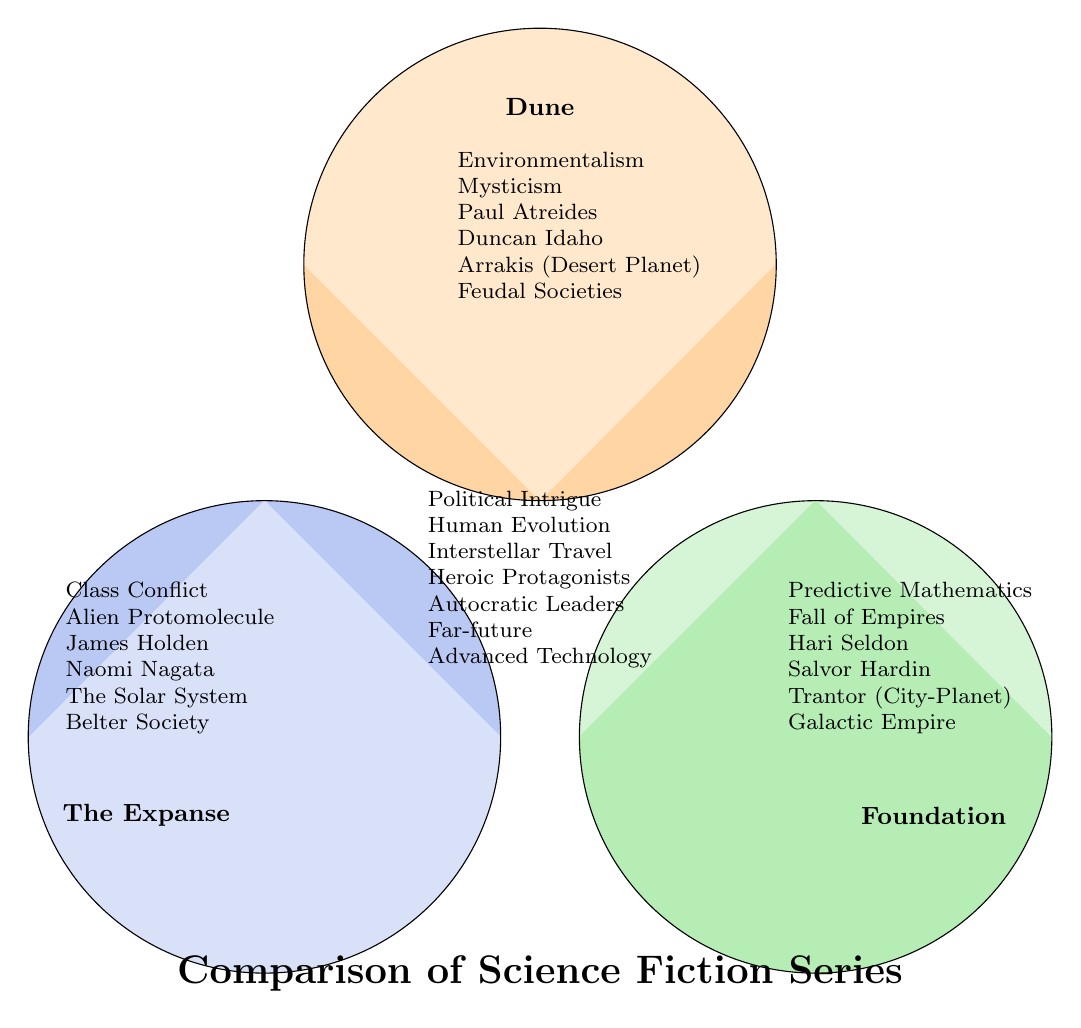What themes are unique to Dune? By examining the "Dune" circle in the Venn diagram, we can see the themes surrounding it, specifically "Environmentalism" and "Mysticism," which are not shared with "The Expanse" or "Foundation."
Answer: Environmentalism, Mysticism What characters are associated with The Expanse? The characters listed within the "The Expanse" section of the diagram include "James Holden" and "Naomi Nagata," which are unique to that series.
Answer: James Holden, Naomi Nagata How many common themes do all three series share? The central overlapping area of the Venn diagram lists common themes, which include six themes: "Political Intrigue," "Human Evolution," "Interstellar Travel," "Heroic Protagonists," "Autocratic Leaders," and "Far-future."
Answer: 6 Which setting is depicted in the Foundation series? In the area designated for "Foundation," the setting listed is "Trantor (City-Planet)," highlighting its unique element compared to the other series.
Answer: Trantor (City-Planet) What is the relationship between Dune and The Expanse? The overlapping section between "Dune" and "The Expanse" contains no information indicating specific shared themes or characters, implying that there are no unique similarities between the two in this diagram.
Answer: None Which character is common to both Dune and Foundation? Upon examining each series, there are no characters listed that overlap between the individual sections of "Dune" and "Foundation," meaning there are no shared characters.
Answer: None How is the theme of "Galactic Empire" represented? The theme of "Galactic Empire" appears uniquely in the "Foundation" section of the diagram and does not overlap with "Dune" or "The Expanse," indicating it is specific to Foundation.
Answer: Foundation How many series feature the theme of "Interstellar Travel"? The theme is listed in the central overlapping area of the diagram, indicating that all three series feature it, confirming its presence in "Dune," "The Expanse," and "Foundation."
Answer: 3 What is the setting common to Dune and The Expanse? The diagram demonstrates that the specific settings of "Dune" and "The Expanse" do not overlap, as both have distinct settings, thereby confirming there isn't a shared setting between them.
Answer: None 